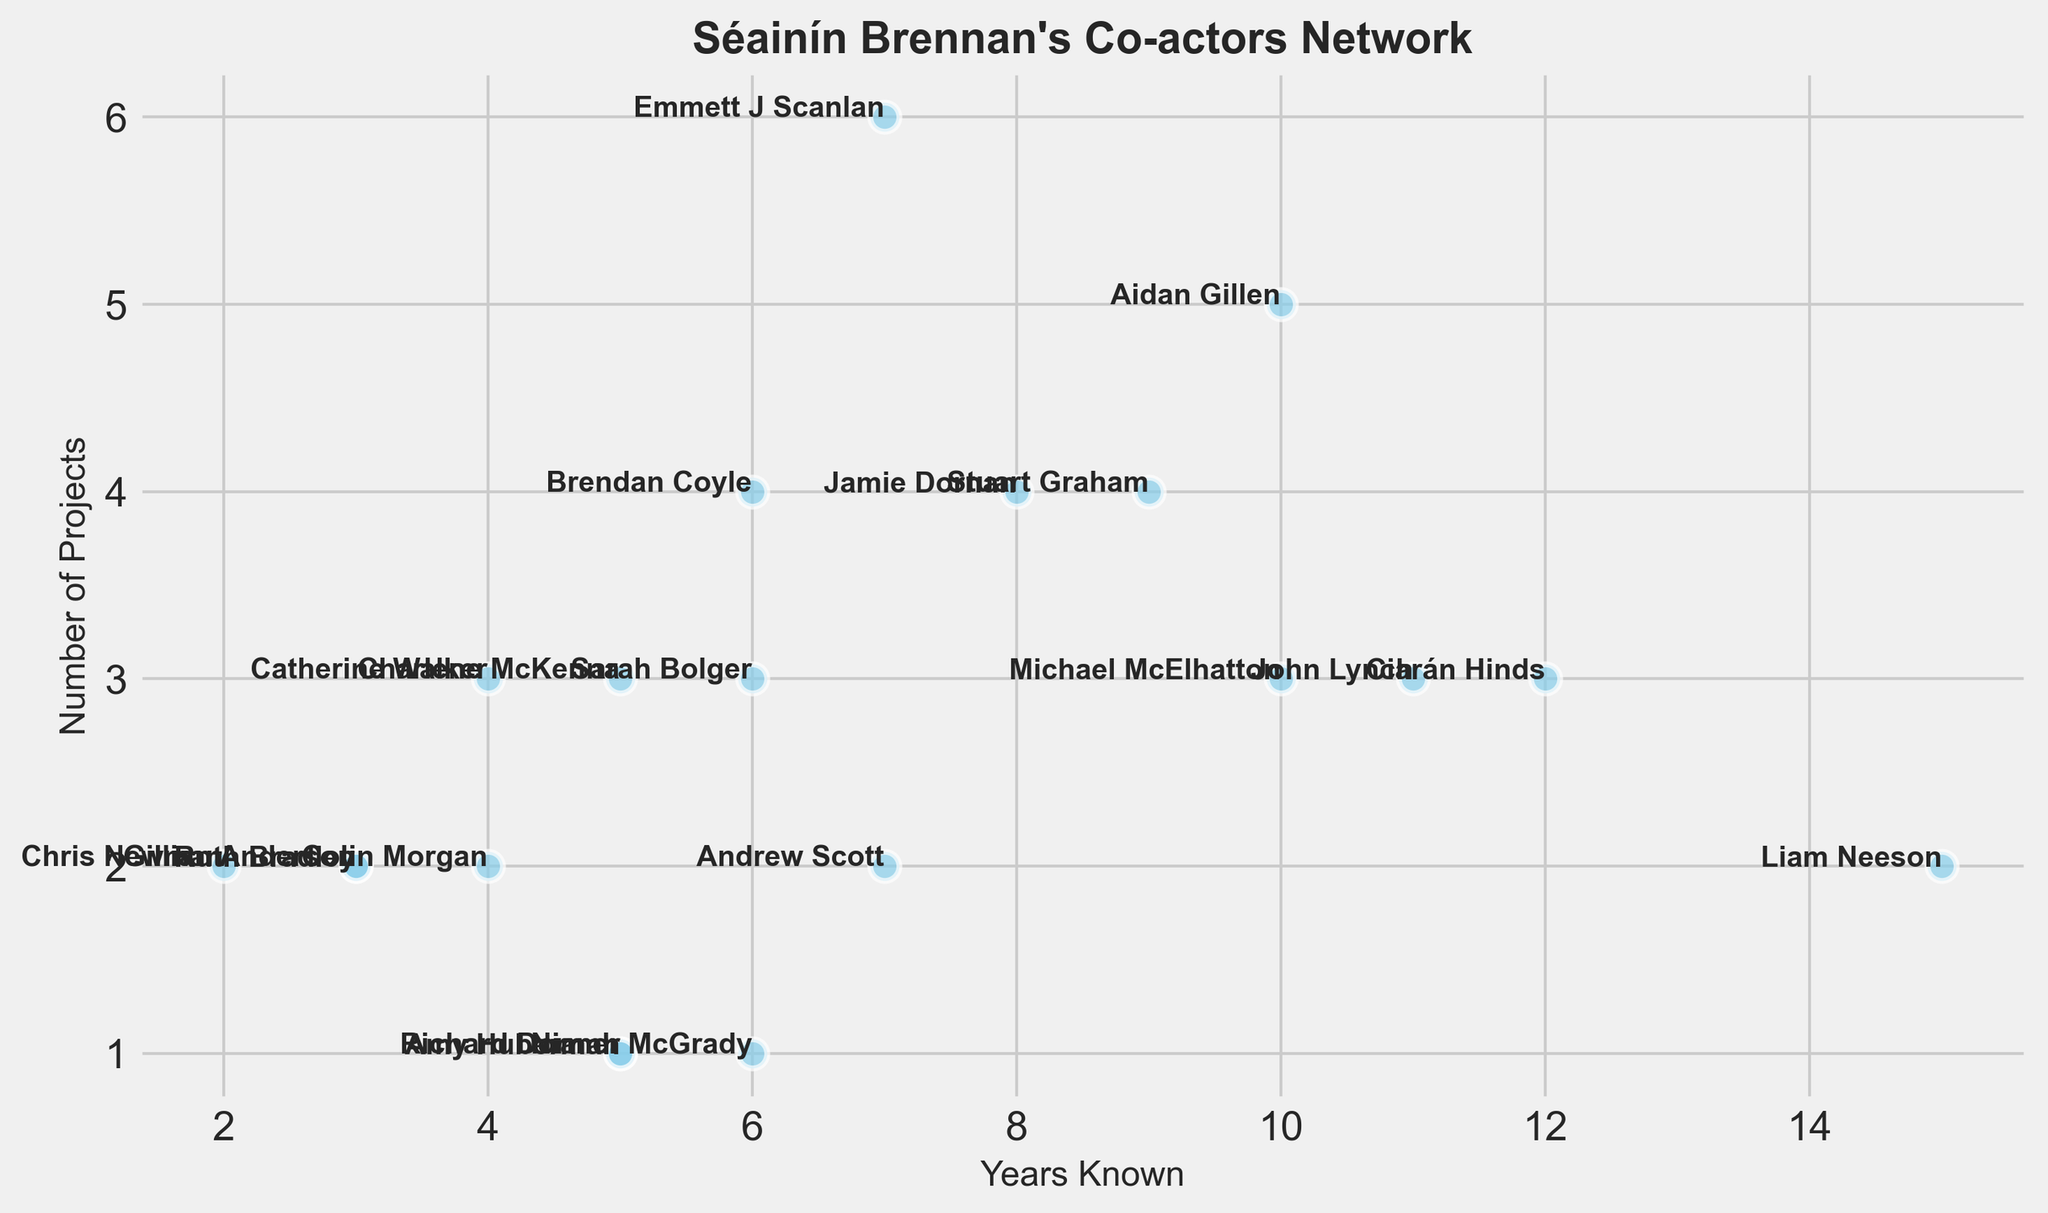Who has Séainín Brennan known the longest? Find the data point with the highest value on the x-axis (Years Known). Liam Neeson has "Years Known" as 15, which is the highest.
Answer: Liam Neeson How many projects has Séainín Brennan done with Emmett J Scanlan? Find Emmett J Scanlan's data point and refer to the y-axis value (Number of Projects), which is 6.
Answer: 6 Which co-actor has worked on the most projects with Séainín Brennan? Look for the data point with the highest value on the y-axis (Number of Projects), which is Emmett J Scanlan with 6 projects.
Answer: Emmett J Scanlan Is Stuart Graham's number of projects greater than or equal to that of Ruth Bradley? Compare Stuart Graham's y-axis value (Number of Projects), which is 4, with Ruth Bradley's, which is 2.
Answer: Yes What are the total years Séainín Brennan has known Ciarán Hinds and John Lynch? Add the "Years Known" values of Ciarán Hinds (12) and John Lynch (11). 12 + 11 = 23.
Answer: 23 Who has worked on more projects with Séainín Brennan: Jamie Dornan or Brendan Coyle? Compare the y-axis values for Jamie Dornan (4) and Brendan Coyle (4).
Answer: It's a tie with both having 4 projects Calculate the average number of projects for co-actors known for at least 10 years. Identify co-actors with "Years Known" of at least 10 (Aidan Gillen, Ciarán Hinds, Liam Neeson, Michael McElhatton, John Lynch). Sum their "Number of Projects" (5 + 3 + 2 + 3 + 3 = 16) and divide by the number of co-actors (5). 16 / 5 = 3.2.
Answer: 3.2 Which co-actor has the fewest projects with Séainín Brennan and how many years have they known each other? Identify the data point with the lowest y-axis value (Number of Projects), which is Amy Huberman, with 1 project and 5 years known.
Answer: Amy Huberman, 5 years What is the difference in the number of projects between the co-actors Séainín Brennan has known for the longest and the shortest times? Identify co-actors with the highest "Years Known" (Liam Neeson, 15 years, 2 projects) and the lowest (Chris Newman, 2 years, 2 projects). Calculate the difference in "Number of Projects" which is 2 - 2 = 0.
Answer: 0 